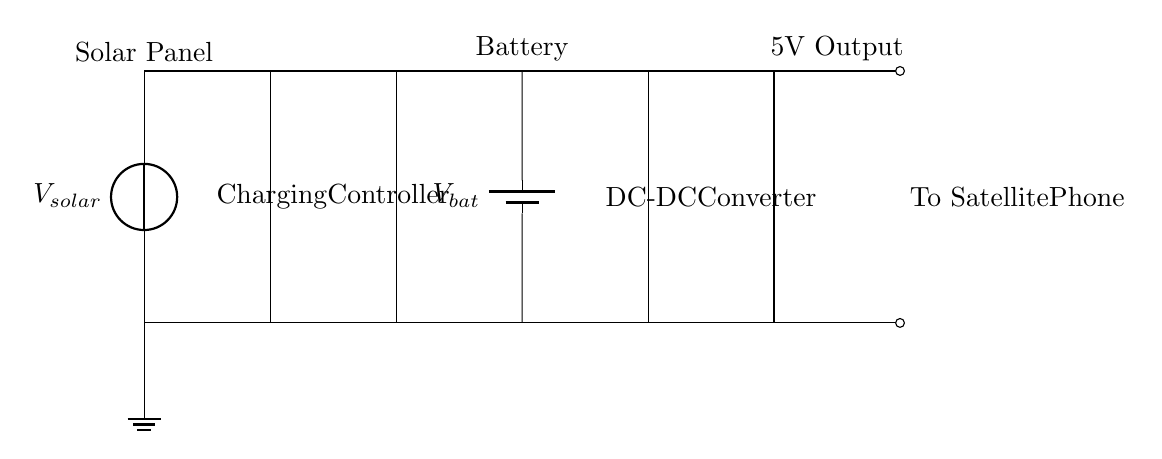What is the voltage of the solar panel? The voltage of the solar panel is denoted by \( V_{solar} \) in the circuit diagram. This represents the voltage generated by the solar panel when exposed to sunlight.
Answer: V solar What is the function of the charging controller? The role of the charging controller in the circuit is to manage the flow of electricity from the solar panel to the battery, ensuring that the battery is charged appropriately without overcharging or damaging it.
Answer: Manage charging What type of battery is used in the circuit? The battery is labeled as \( V_{bat} \) in the diagram, indicating a rechargeable battery that stores the electrical energy captured by the solar panel for later use.
Answer: Rechargeable What is the output voltage of the DC-DC converter? In the circuit, the output voltage is specified as 5V, which is essential for powering the satellite phone. This means the DC-DC converter steps down or regulates the voltage to ensure compatibility with the device being powered.
Answer: 5V How are the components connected in series or parallel? The connection between the solar panel, charging controller, battery, and DC-DC converter is primarily in series. This means each component is connected end-to-end, allowing the current to flow through each component sequentially from the solar panel to the satellite phone.
Answer: Series connection What is the purpose of the DC-DC converter in the circuit? The DC-DC converter's purpose is to convert the voltage from the battery to a consistent 5V output suitable for the satellite phone. It ensures that the device receives the correct voltage for operation, regardless of the variations in battery voltage.
Answer: Voltage conversion What component stores electrical energy in the circuit? The battery is the component that stores electrical energy in this circuit. It captures energy generated by the solar panel, allowing it to be used later when there is no sunlight or direct power from the panel.
Answer: Battery 